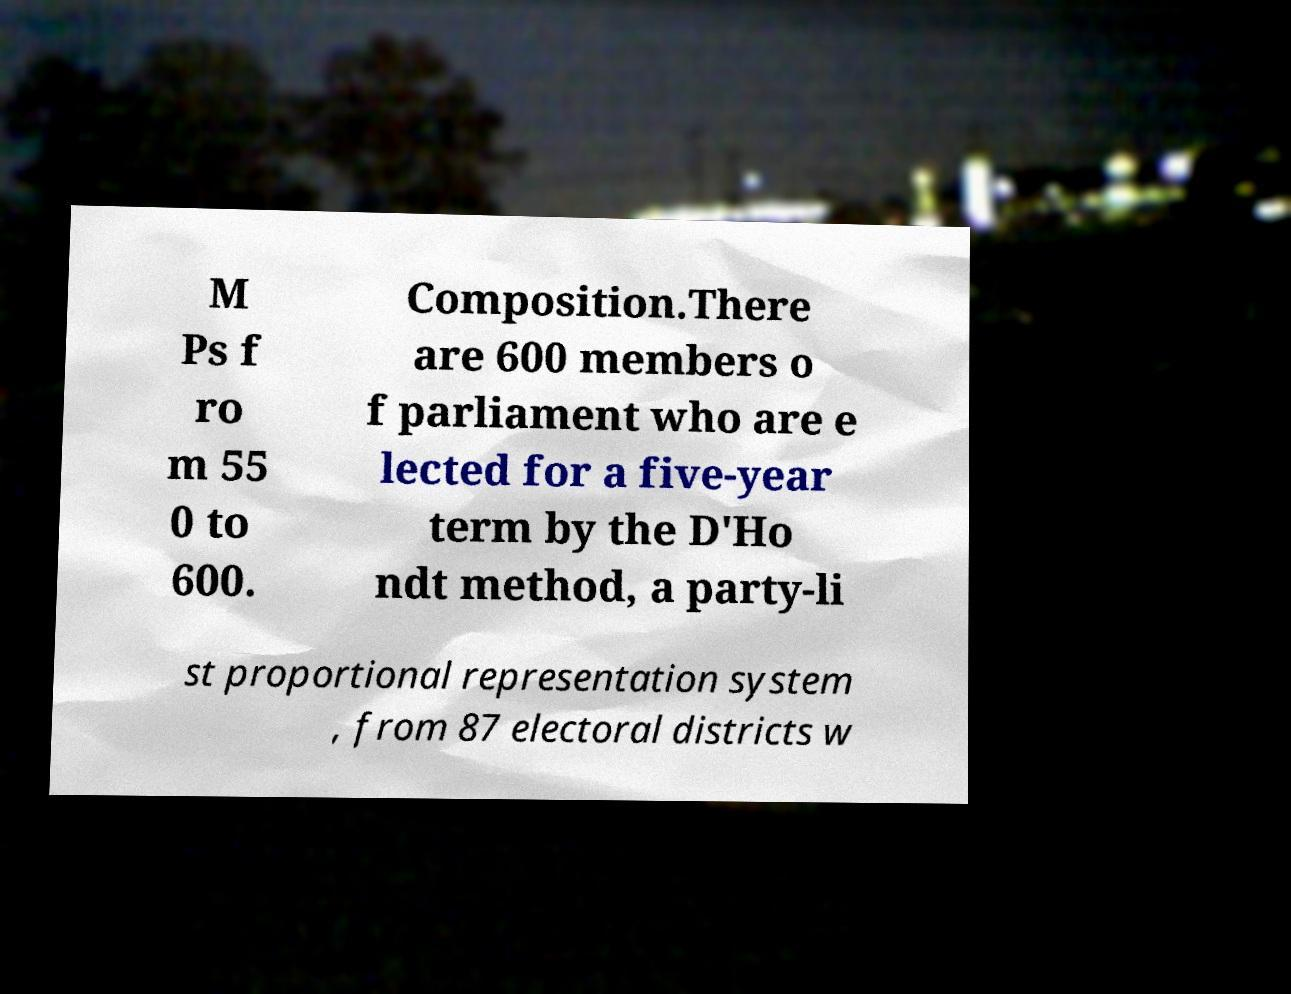Could you assist in decoding the text presented in this image and type it out clearly? M Ps f ro m 55 0 to 600. Composition.There are 600 members o f parliament who are e lected for a five-year term by the D'Ho ndt method, a party-li st proportional representation system , from 87 electoral districts w 